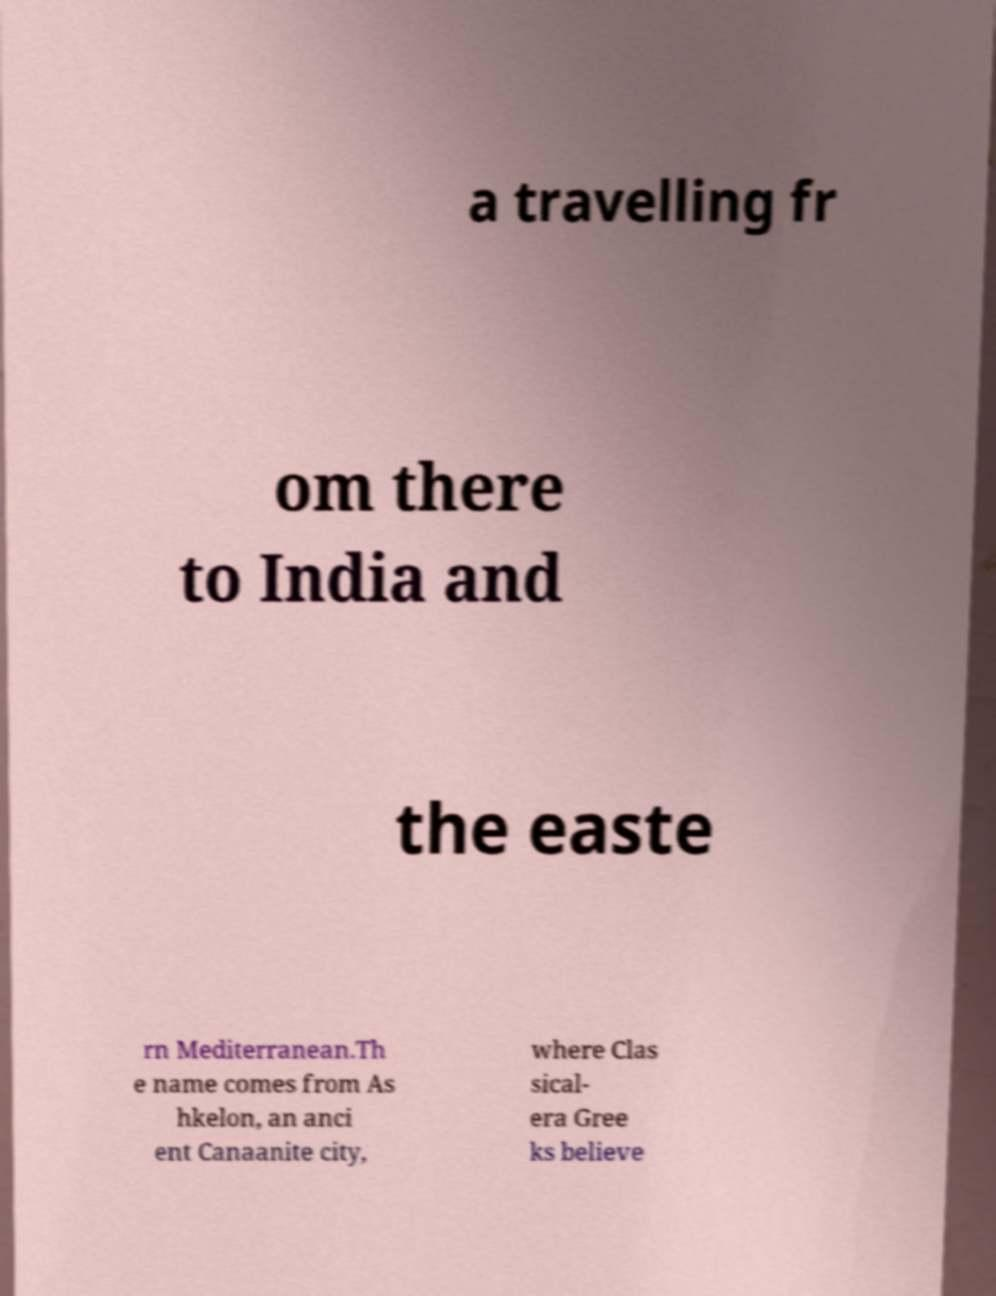What messages or text are displayed in this image? I need them in a readable, typed format. a travelling fr om there to India and the easte rn Mediterranean.Th e name comes from As hkelon, an anci ent Canaanite city, where Clas sical- era Gree ks believe 